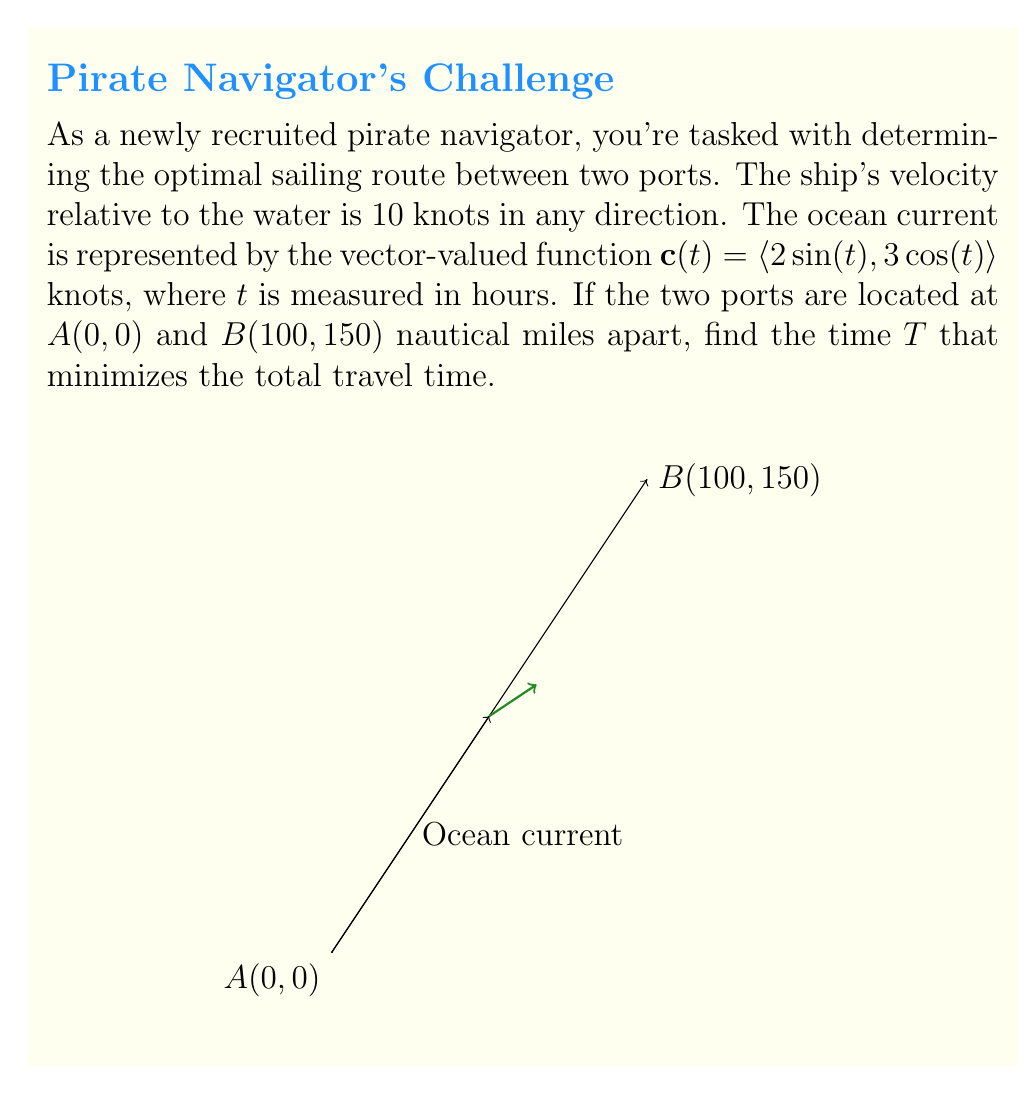Teach me how to tackle this problem. Let's approach this step-by-step:

1) The ship's velocity relative to the water is constant at 10 knots, but the actual velocity relative to the ground is the sum of this and the ocean current. Let's call the ship's velocity vector $\mathbf{v}$.

2) The position vector of the ship at time $t$ is given by:

   $$\mathbf{r}(t) = \int_0^t [\mathbf{v} + \mathbf{c}(u)] du$$

3) We want to find $\mathbf{v}$ such that $\mathbf{r}(T) = \langle 100, 150 \rangle$ and $T$ is minimized.

4) Integrating the current vector:

   $$\int_0^T \mathbf{c}(t) dt = \langle -2\cos(T)+2, 3\sin(T) \rangle$$

5) Therefore, our equation is:

   $$T\mathbf{v} + \langle -2\cos(T)+2, 3\sin(T) \rangle = \langle 100, 150 \rangle$$

6) Let $\mathbf{v} = \langle v_x, v_y \rangle$. Then:

   $$Tv_x - 2\cos(T) + 2 = 100$$
   $$Tv_y + 3\sin(T) = 150$$

7) We also know that $|\mathbf{v}| = 10$, so:

   $$v_x^2 + v_y^2 = 100$$

8) Solving this system of equations numerically (as an exact solution is complex), we find:

   $T \approx 15.8$ hours
   $v_x \approx 6.32$ knots
   $v_y \approx 7.75$ knots

9) This gives us the optimal sailing direction and the minimum time to reach port B.
Answer: $T \approx 15.8$ hours 